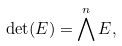<formula> <loc_0><loc_0><loc_500><loc_500>\det ( E ) = \bigwedge ^ { n } E ,</formula> 